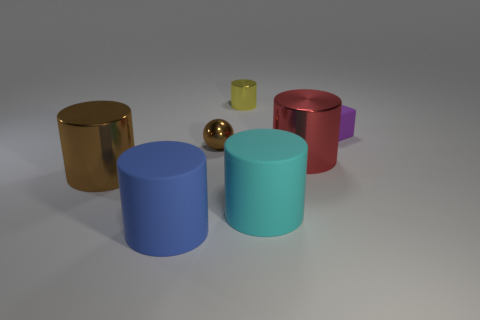Subtract all gray cylinders. Subtract all cyan balls. How many cylinders are left? 5 Add 1 tiny yellow metallic blocks. How many objects exist? 8 Subtract all blocks. How many objects are left? 6 Subtract all red cylinders. Subtract all small objects. How many objects are left? 3 Add 5 cyan matte cylinders. How many cyan matte cylinders are left? 6 Add 6 yellow objects. How many yellow objects exist? 7 Subtract 0 cyan blocks. How many objects are left? 7 